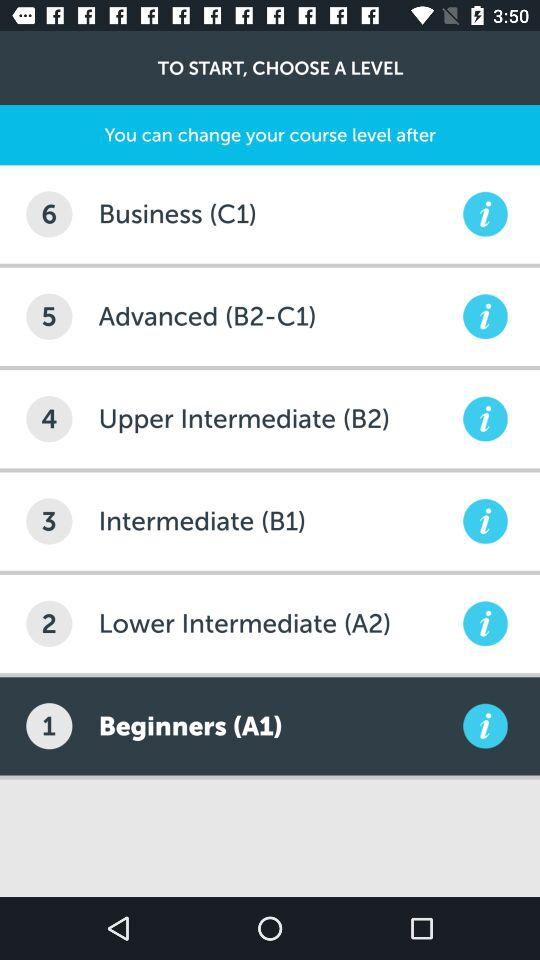What is the selected course level? The selected course level is "Beginners (A1)". 